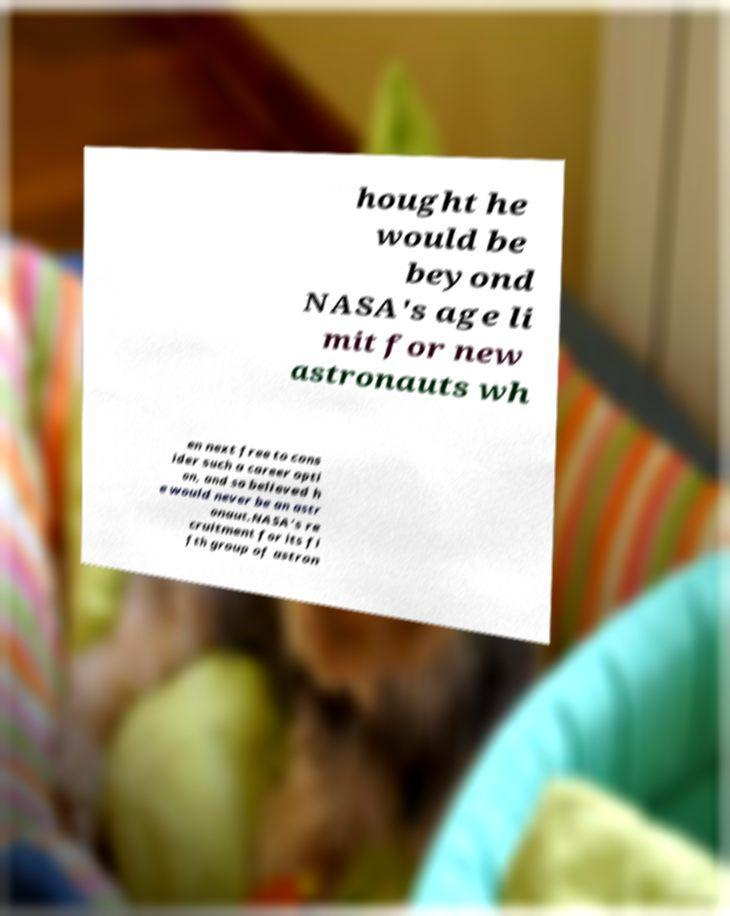Please identify and transcribe the text found in this image. hought he would be beyond NASA's age li mit for new astronauts wh en next free to cons ider such a career opti on, and so believed h e would never be an astr onaut.NASA's re cruitment for its fi fth group of astron 